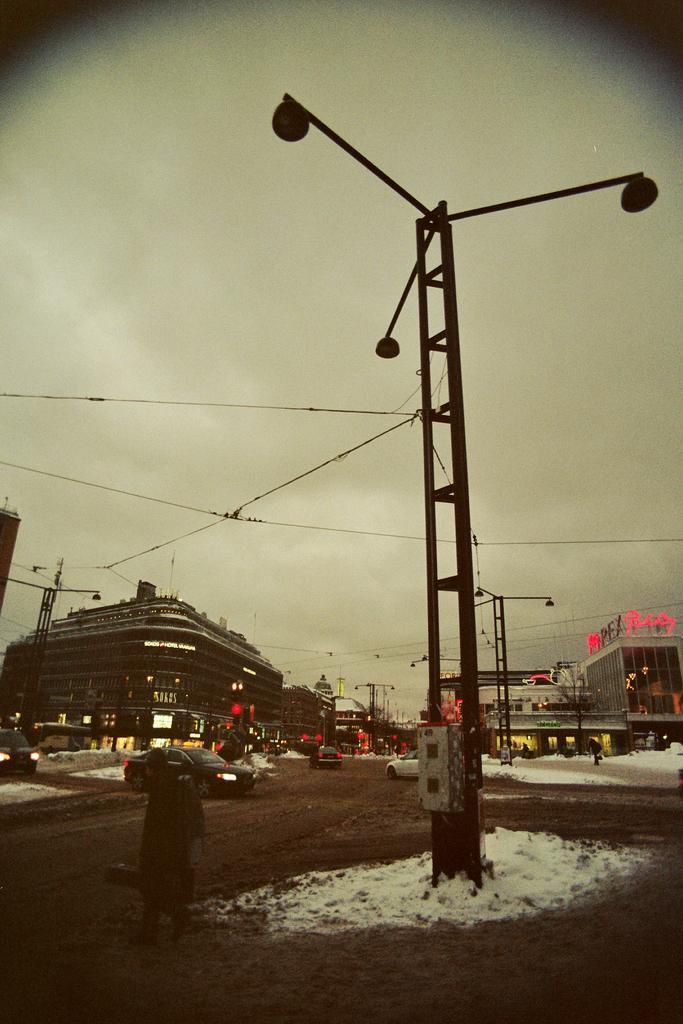What structures can be seen in the image? There are buildings in the image. What objects are present in the image that emit light? Lights are visible in the image. Can you describe the person in the image? There is a person at the bottom of the image. What type of vehicles can be seen in the image? Cars are present in the image. What is the weather like in the image? There is snow in the image. What can be seen in the background of the image? Wires and the sky are visible in the background of the image. Is the person in the image wearing a vest? There is no information about the person's clothing in the image, so it cannot be determined if they are wearing a vest. How does the person in the image interact with the quicksand? There is no quicksand present in the image; it features snow and other elements mentioned in the facts. 